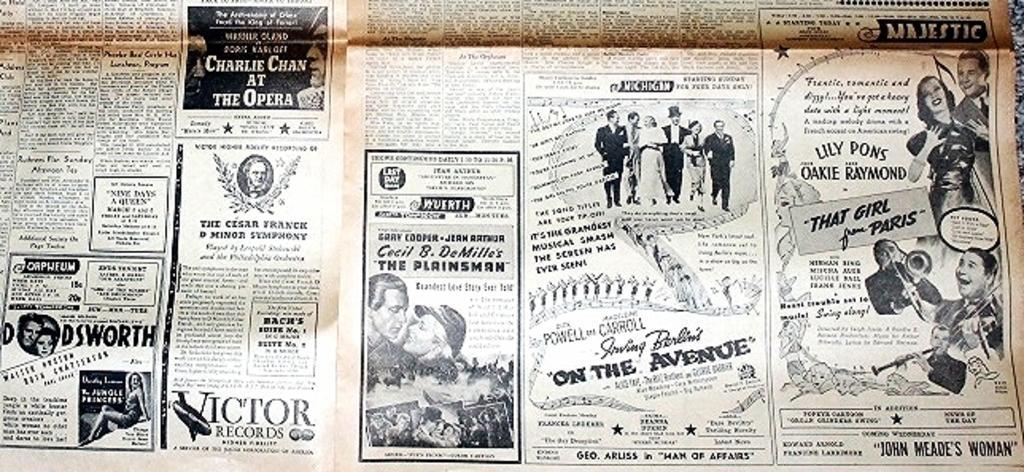Can you describe this image briefly? In this image I can see the newspaper articles in which I can see few pictures of persons. I can see few of them are standing, few are holding musical instruments, a woman is sitting and I can see all of them are black and white pictures. 